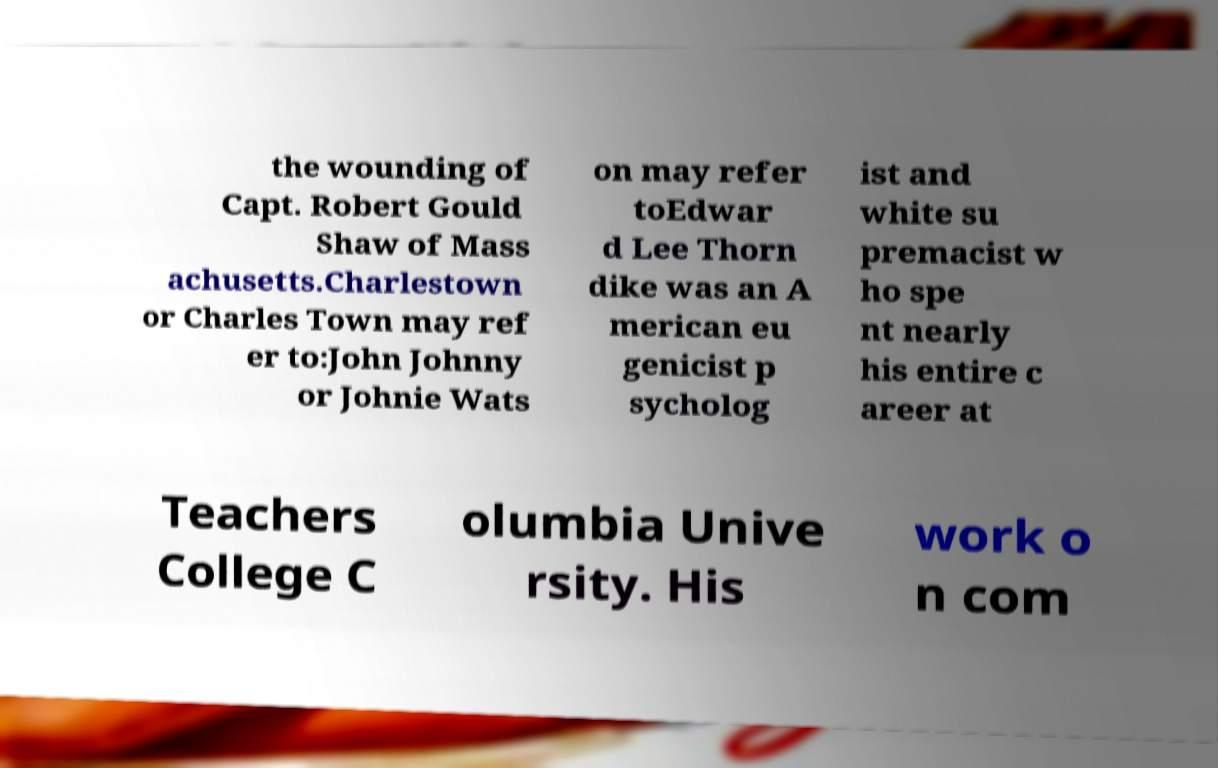Please identify and transcribe the text found in this image. the wounding of Capt. Robert Gould Shaw of Mass achusetts.Charlestown or Charles Town may ref er to:John Johnny or Johnie Wats on may refer toEdwar d Lee Thorn dike was an A merican eu genicist p sycholog ist and white su premacist w ho spe nt nearly his entire c areer at Teachers College C olumbia Unive rsity. His work o n com 